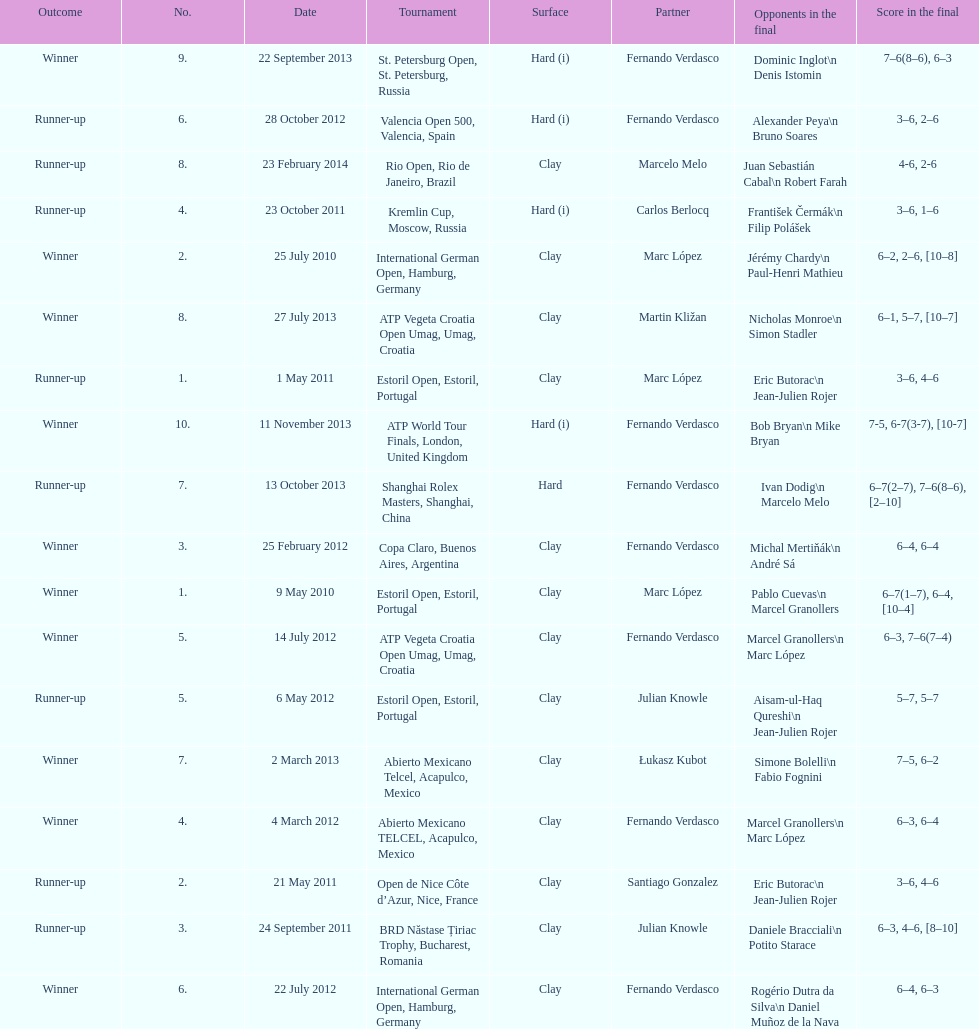What is the number of winning outcomes? 10. 